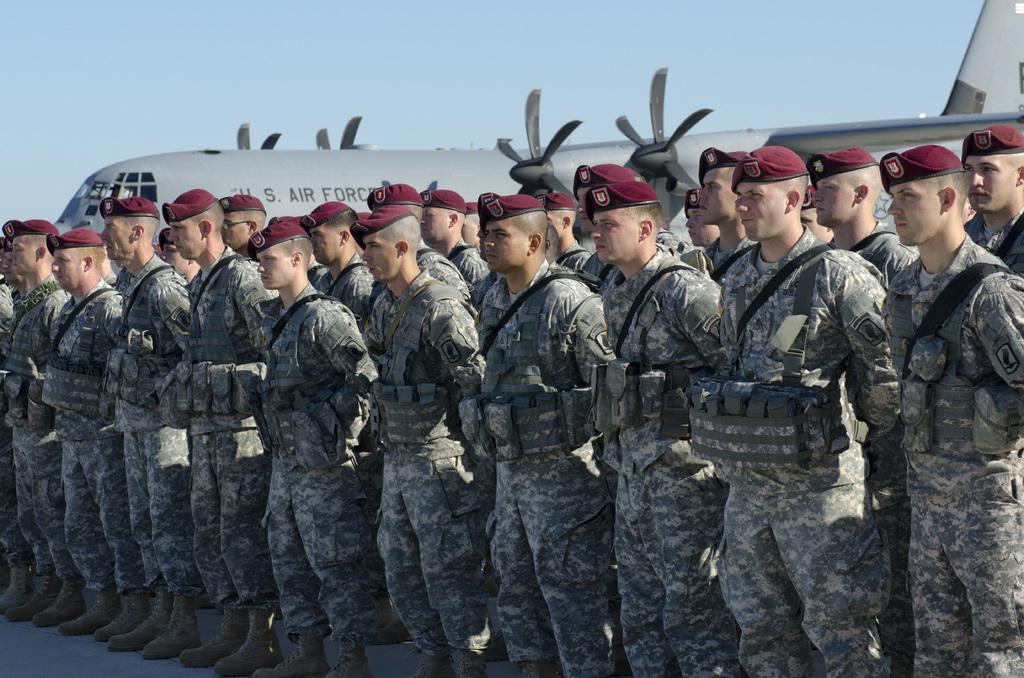How many people are in the image? There is a group of people in the image. What are the people doing in the image? The people are standing on the ground. What are the people wearing in the image? The people are wearing uniforms and hats. What can be seen in the background of the image? There is a sky and an airplane visible in the background of the image. What type of lettuce is being used to cook in the image? There is no lettuce or cooking activity present in the image. How does the group of people resolve their disagreements in the image? The image does not show any disagreements or conflicts among the group of people. 